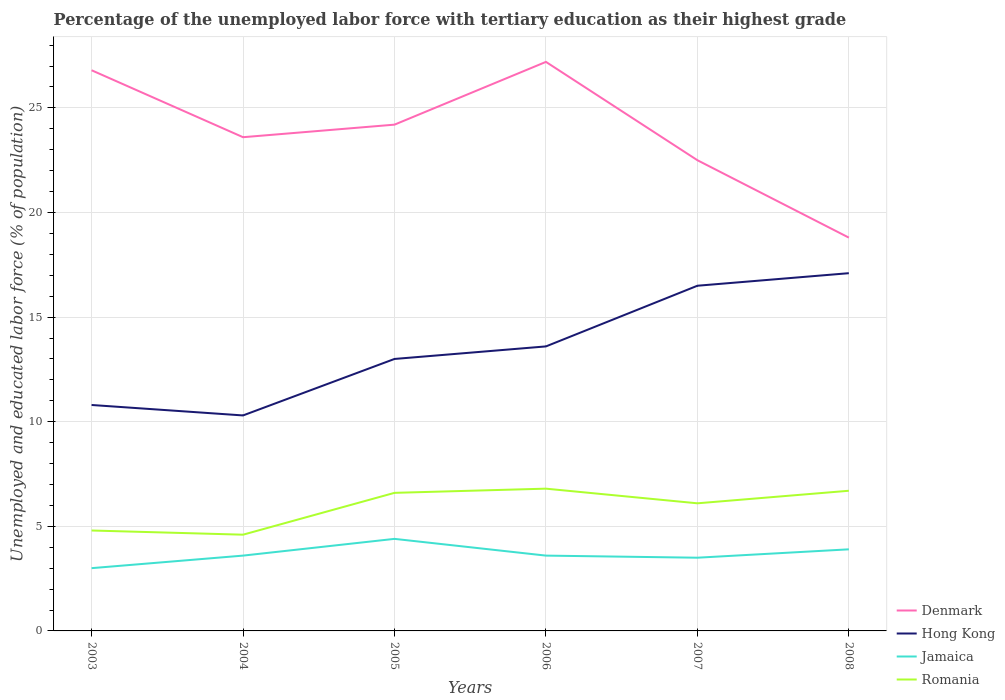Does the line corresponding to Hong Kong intersect with the line corresponding to Jamaica?
Your response must be concise. No. Is the number of lines equal to the number of legend labels?
Your response must be concise. Yes. Across all years, what is the maximum percentage of the unemployed labor force with tertiary education in Jamaica?
Ensure brevity in your answer.  3. What is the difference between the highest and the second highest percentage of the unemployed labor force with tertiary education in Jamaica?
Your answer should be very brief. 1.4. How many lines are there?
Give a very brief answer. 4. How many years are there in the graph?
Your response must be concise. 6. Does the graph contain any zero values?
Provide a succinct answer. No. Does the graph contain grids?
Provide a short and direct response. Yes. What is the title of the graph?
Your response must be concise. Percentage of the unemployed labor force with tertiary education as their highest grade. Does "Moldova" appear as one of the legend labels in the graph?
Ensure brevity in your answer.  No. What is the label or title of the X-axis?
Provide a short and direct response. Years. What is the label or title of the Y-axis?
Give a very brief answer. Unemployed and educated labor force (% of population). What is the Unemployed and educated labor force (% of population) of Denmark in 2003?
Ensure brevity in your answer.  26.8. What is the Unemployed and educated labor force (% of population) in Hong Kong in 2003?
Offer a terse response. 10.8. What is the Unemployed and educated labor force (% of population) of Romania in 2003?
Make the answer very short. 4.8. What is the Unemployed and educated labor force (% of population) in Denmark in 2004?
Make the answer very short. 23.6. What is the Unemployed and educated labor force (% of population) in Hong Kong in 2004?
Offer a very short reply. 10.3. What is the Unemployed and educated labor force (% of population) in Jamaica in 2004?
Your answer should be very brief. 3.6. What is the Unemployed and educated labor force (% of population) of Romania in 2004?
Make the answer very short. 4.6. What is the Unemployed and educated labor force (% of population) of Denmark in 2005?
Keep it short and to the point. 24.2. What is the Unemployed and educated labor force (% of population) in Jamaica in 2005?
Your answer should be compact. 4.4. What is the Unemployed and educated labor force (% of population) of Romania in 2005?
Provide a succinct answer. 6.6. What is the Unemployed and educated labor force (% of population) of Denmark in 2006?
Make the answer very short. 27.2. What is the Unemployed and educated labor force (% of population) of Hong Kong in 2006?
Keep it short and to the point. 13.6. What is the Unemployed and educated labor force (% of population) of Jamaica in 2006?
Provide a short and direct response. 3.6. What is the Unemployed and educated labor force (% of population) of Romania in 2006?
Ensure brevity in your answer.  6.8. What is the Unemployed and educated labor force (% of population) in Denmark in 2007?
Your answer should be very brief. 22.5. What is the Unemployed and educated labor force (% of population) of Jamaica in 2007?
Your answer should be compact. 3.5. What is the Unemployed and educated labor force (% of population) in Romania in 2007?
Make the answer very short. 6.1. What is the Unemployed and educated labor force (% of population) in Denmark in 2008?
Your answer should be very brief. 18.8. What is the Unemployed and educated labor force (% of population) of Hong Kong in 2008?
Offer a very short reply. 17.1. What is the Unemployed and educated labor force (% of population) in Jamaica in 2008?
Give a very brief answer. 3.9. What is the Unemployed and educated labor force (% of population) in Romania in 2008?
Provide a succinct answer. 6.7. Across all years, what is the maximum Unemployed and educated labor force (% of population) of Denmark?
Give a very brief answer. 27.2. Across all years, what is the maximum Unemployed and educated labor force (% of population) in Hong Kong?
Provide a short and direct response. 17.1. Across all years, what is the maximum Unemployed and educated labor force (% of population) in Jamaica?
Keep it short and to the point. 4.4. Across all years, what is the maximum Unemployed and educated labor force (% of population) in Romania?
Your answer should be compact. 6.8. Across all years, what is the minimum Unemployed and educated labor force (% of population) in Denmark?
Your answer should be compact. 18.8. Across all years, what is the minimum Unemployed and educated labor force (% of population) of Hong Kong?
Offer a terse response. 10.3. Across all years, what is the minimum Unemployed and educated labor force (% of population) in Romania?
Provide a short and direct response. 4.6. What is the total Unemployed and educated labor force (% of population) of Denmark in the graph?
Your answer should be compact. 143.1. What is the total Unemployed and educated labor force (% of population) in Hong Kong in the graph?
Give a very brief answer. 81.3. What is the total Unemployed and educated labor force (% of population) in Romania in the graph?
Ensure brevity in your answer.  35.6. What is the difference between the Unemployed and educated labor force (% of population) in Jamaica in 2003 and that in 2004?
Provide a succinct answer. -0.6. What is the difference between the Unemployed and educated labor force (% of population) of Denmark in 2003 and that in 2005?
Your answer should be very brief. 2.6. What is the difference between the Unemployed and educated labor force (% of population) in Hong Kong in 2003 and that in 2005?
Offer a very short reply. -2.2. What is the difference between the Unemployed and educated labor force (% of population) in Romania in 2003 and that in 2005?
Ensure brevity in your answer.  -1.8. What is the difference between the Unemployed and educated labor force (% of population) in Denmark in 2003 and that in 2006?
Your response must be concise. -0.4. What is the difference between the Unemployed and educated labor force (% of population) in Hong Kong in 2003 and that in 2006?
Make the answer very short. -2.8. What is the difference between the Unemployed and educated labor force (% of population) in Jamaica in 2003 and that in 2006?
Provide a short and direct response. -0.6. What is the difference between the Unemployed and educated labor force (% of population) in Romania in 2003 and that in 2006?
Your response must be concise. -2. What is the difference between the Unemployed and educated labor force (% of population) in Jamaica in 2003 and that in 2007?
Your response must be concise. -0.5. What is the difference between the Unemployed and educated labor force (% of population) in Romania in 2003 and that in 2007?
Provide a succinct answer. -1.3. What is the difference between the Unemployed and educated labor force (% of population) of Denmark in 2003 and that in 2008?
Offer a terse response. 8. What is the difference between the Unemployed and educated labor force (% of population) in Jamaica in 2003 and that in 2008?
Offer a terse response. -0.9. What is the difference between the Unemployed and educated labor force (% of population) in Denmark in 2004 and that in 2005?
Ensure brevity in your answer.  -0.6. What is the difference between the Unemployed and educated labor force (% of population) in Romania in 2004 and that in 2005?
Make the answer very short. -2. What is the difference between the Unemployed and educated labor force (% of population) in Denmark in 2004 and that in 2007?
Your response must be concise. 1.1. What is the difference between the Unemployed and educated labor force (% of population) in Romania in 2004 and that in 2007?
Offer a terse response. -1.5. What is the difference between the Unemployed and educated labor force (% of population) of Jamaica in 2004 and that in 2008?
Keep it short and to the point. -0.3. What is the difference between the Unemployed and educated labor force (% of population) in Denmark in 2005 and that in 2006?
Your answer should be very brief. -3. What is the difference between the Unemployed and educated labor force (% of population) in Jamaica in 2005 and that in 2007?
Your answer should be very brief. 0.9. What is the difference between the Unemployed and educated labor force (% of population) in Romania in 2005 and that in 2007?
Ensure brevity in your answer.  0.5. What is the difference between the Unemployed and educated labor force (% of population) in Denmark in 2005 and that in 2008?
Provide a short and direct response. 5.4. What is the difference between the Unemployed and educated labor force (% of population) of Jamaica in 2005 and that in 2008?
Make the answer very short. 0.5. What is the difference between the Unemployed and educated labor force (% of population) of Denmark in 2006 and that in 2007?
Provide a succinct answer. 4.7. What is the difference between the Unemployed and educated labor force (% of population) of Hong Kong in 2006 and that in 2007?
Your answer should be very brief. -2.9. What is the difference between the Unemployed and educated labor force (% of population) of Jamaica in 2006 and that in 2007?
Offer a terse response. 0.1. What is the difference between the Unemployed and educated labor force (% of population) of Hong Kong in 2007 and that in 2008?
Provide a succinct answer. -0.6. What is the difference between the Unemployed and educated labor force (% of population) in Jamaica in 2007 and that in 2008?
Keep it short and to the point. -0.4. What is the difference between the Unemployed and educated labor force (% of population) in Romania in 2007 and that in 2008?
Offer a very short reply. -0.6. What is the difference between the Unemployed and educated labor force (% of population) of Denmark in 2003 and the Unemployed and educated labor force (% of population) of Hong Kong in 2004?
Make the answer very short. 16.5. What is the difference between the Unemployed and educated labor force (% of population) of Denmark in 2003 and the Unemployed and educated labor force (% of population) of Jamaica in 2004?
Offer a terse response. 23.2. What is the difference between the Unemployed and educated labor force (% of population) of Hong Kong in 2003 and the Unemployed and educated labor force (% of population) of Jamaica in 2004?
Your answer should be very brief. 7.2. What is the difference between the Unemployed and educated labor force (% of population) in Denmark in 2003 and the Unemployed and educated labor force (% of population) in Hong Kong in 2005?
Your answer should be compact. 13.8. What is the difference between the Unemployed and educated labor force (% of population) of Denmark in 2003 and the Unemployed and educated labor force (% of population) of Jamaica in 2005?
Offer a very short reply. 22.4. What is the difference between the Unemployed and educated labor force (% of population) in Denmark in 2003 and the Unemployed and educated labor force (% of population) in Romania in 2005?
Offer a terse response. 20.2. What is the difference between the Unemployed and educated labor force (% of population) of Jamaica in 2003 and the Unemployed and educated labor force (% of population) of Romania in 2005?
Ensure brevity in your answer.  -3.6. What is the difference between the Unemployed and educated labor force (% of population) in Denmark in 2003 and the Unemployed and educated labor force (% of population) in Jamaica in 2006?
Offer a very short reply. 23.2. What is the difference between the Unemployed and educated labor force (% of population) in Denmark in 2003 and the Unemployed and educated labor force (% of population) in Romania in 2006?
Your answer should be compact. 20. What is the difference between the Unemployed and educated labor force (% of population) of Hong Kong in 2003 and the Unemployed and educated labor force (% of population) of Jamaica in 2006?
Make the answer very short. 7.2. What is the difference between the Unemployed and educated labor force (% of population) of Hong Kong in 2003 and the Unemployed and educated labor force (% of population) of Romania in 2006?
Your answer should be very brief. 4. What is the difference between the Unemployed and educated labor force (% of population) of Denmark in 2003 and the Unemployed and educated labor force (% of population) of Hong Kong in 2007?
Provide a short and direct response. 10.3. What is the difference between the Unemployed and educated labor force (% of population) of Denmark in 2003 and the Unemployed and educated labor force (% of population) of Jamaica in 2007?
Ensure brevity in your answer.  23.3. What is the difference between the Unemployed and educated labor force (% of population) in Denmark in 2003 and the Unemployed and educated labor force (% of population) in Romania in 2007?
Your answer should be compact. 20.7. What is the difference between the Unemployed and educated labor force (% of population) in Hong Kong in 2003 and the Unemployed and educated labor force (% of population) in Jamaica in 2007?
Give a very brief answer. 7.3. What is the difference between the Unemployed and educated labor force (% of population) of Denmark in 2003 and the Unemployed and educated labor force (% of population) of Jamaica in 2008?
Your response must be concise. 22.9. What is the difference between the Unemployed and educated labor force (% of population) of Denmark in 2003 and the Unemployed and educated labor force (% of population) of Romania in 2008?
Provide a succinct answer. 20.1. What is the difference between the Unemployed and educated labor force (% of population) in Hong Kong in 2003 and the Unemployed and educated labor force (% of population) in Jamaica in 2008?
Ensure brevity in your answer.  6.9. What is the difference between the Unemployed and educated labor force (% of population) in Hong Kong in 2003 and the Unemployed and educated labor force (% of population) in Romania in 2008?
Make the answer very short. 4.1. What is the difference between the Unemployed and educated labor force (% of population) of Jamaica in 2003 and the Unemployed and educated labor force (% of population) of Romania in 2008?
Give a very brief answer. -3.7. What is the difference between the Unemployed and educated labor force (% of population) of Denmark in 2004 and the Unemployed and educated labor force (% of population) of Hong Kong in 2005?
Your answer should be compact. 10.6. What is the difference between the Unemployed and educated labor force (% of population) in Hong Kong in 2004 and the Unemployed and educated labor force (% of population) in Jamaica in 2005?
Make the answer very short. 5.9. What is the difference between the Unemployed and educated labor force (% of population) of Hong Kong in 2004 and the Unemployed and educated labor force (% of population) of Romania in 2005?
Your response must be concise. 3.7. What is the difference between the Unemployed and educated labor force (% of population) in Denmark in 2004 and the Unemployed and educated labor force (% of population) in Jamaica in 2006?
Provide a short and direct response. 20. What is the difference between the Unemployed and educated labor force (% of population) of Denmark in 2004 and the Unemployed and educated labor force (% of population) of Romania in 2006?
Give a very brief answer. 16.8. What is the difference between the Unemployed and educated labor force (% of population) of Jamaica in 2004 and the Unemployed and educated labor force (% of population) of Romania in 2006?
Offer a terse response. -3.2. What is the difference between the Unemployed and educated labor force (% of population) in Denmark in 2004 and the Unemployed and educated labor force (% of population) in Jamaica in 2007?
Provide a succinct answer. 20.1. What is the difference between the Unemployed and educated labor force (% of population) in Denmark in 2004 and the Unemployed and educated labor force (% of population) in Romania in 2008?
Make the answer very short. 16.9. What is the difference between the Unemployed and educated labor force (% of population) in Hong Kong in 2004 and the Unemployed and educated labor force (% of population) in Romania in 2008?
Ensure brevity in your answer.  3.6. What is the difference between the Unemployed and educated labor force (% of population) of Jamaica in 2004 and the Unemployed and educated labor force (% of population) of Romania in 2008?
Provide a succinct answer. -3.1. What is the difference between the Unemployed and educated labor force (% of population) of Denmark in 2005 and the Unemployed and educated labor force (% of population) of Jamaica in 2006?
Make the answer very short. 20.6. What is the difference between the Unemployed and educated labor force (% of population) of Hong Kong in 2005 and the Unemployed and educated labor force (% of population) of Jamaica in 2006?
Provide a short and direct response. 9.4. What is the difference between the Unemployed and educated labor force (% of population) in Hong Kong in 2005 and the Unemployed and educated labor force (% of population) in Romania in 2006?
Provide a succinct answer. 6.2. What is the difference between the Unemployed and educated labor force (% of population) of Denmark in 2005 and the Unemployed and educated labor force (% of population) of Jamaica in 2007?
Ensure brevity in your answer.  20.7. What is the difference between the Unemployed and educated labor force (% of population) in Denmark in 2005 and the Unemployed and educated labor force (% of population) in Romania in 2007?
Your answer should be very brief. 18.1. What is the difference between the Unemployed and educated labor force (% of population) of Hong Kong in 2005 and the Unemployed and educated labor force (% of population) of Jamaica in 2007?
Your response must be concise. 9.5. What is the difference between the Unemployed and educated labor force (% of population) of Jamaica in 2005 and the Unemployed and educated labor force (% of population) of Romania in 2007?
Your answer should be very brief. -1.7. What is the difference between the Unemployed and educated labor force (% of population) of Denmark in 2005 and the Unemployed and educated labor force (% of population) of Hong Kong in 2008?
Give a very brief answer. 7.1. What is the difference between the Unemployed and educated labor force (% of population) in Denmark in 2005 and the Unemployed and educated labor force (% of population) in Jamaica in 2008?
Provide a short and direct response. 20.3. What is the difference between the Unemployed and educated labor force (% of population) of Denmark in 2005 and the Unemployed and educated labor force (% of population) of Romania in 2008?
Your answer should be very brief. 17.5. What is the difference between the Unemployed and educated labor force (% of population) of Hong Kong in 2005 and the Unemployed and educated labor force (% of population) of Jamaica in 2008?
Offer a terse response. 9.1. What is the difference between the Unemployed and educated labor force (% of population) in Denmark in 2006 and the Unemployed and educated labor force (% of population) in Hong Kong in 2007?
Give a very brief answer. 10.7. What is the difference between the Unemployed and educated labor force (% of population) in Denmark in 2006 and the Unemployed and educated labor force (% of population) in Jamaica in 2007?
Ensure brevity in your answer.  23.7. What is the difference between the Unemployed and educated labor force (% of population) of Denmark in 2006 and the Unemployed and educated labor force (% of population) of Romania in 2007?
Provide a short and direct response. 21.1. What is the difference between the Unemployed and educated labor force (% of population) of Hong Kong in 2006 and the Unemployed and educated labor force (% of population) of Romania in 2007?
Give a very brief answer. 7.5. What is the difference between the Unemployed and educated labor force (% of population) in Jamaica in 2006 and the Unemployed and educated labor force (% of population) in Romania in 2007?
Give a very brief answer. -2.5. What is the difference between the Unemployed and educated labor force (% of population) in Denmark in 2006 and the Unemployed and educated labor force (% of population) in Jamaica in 2008?
Your answer should be very brief. 23.3. What is the difference between the Unemployed and educated labor force (% of population) in Denmark in 2007 and the Unemployed and educated labor force (% of population) in Jamaica in 2008?
Keep it short and to the point. 18.6. What is the difference between the Unemployed and educated labor force (% of population) of Denmark in 2007 and the Unemployed and educated labor force (% of population) of Romania in 2008?
Your answer should be compact. 15.8. What is the difference between the Unemployed and educated labor force (% of population) of Hong Kong in 2007 and the Unemployed and educated labor force (% of population) of Jamaica in 2008?
Provide a short and direct response. 12.6. What is the difference between the Unemployed and educated labor force (% of population) in Hong Kong in 2007 and the Unemployed and educated labor force (% of population) in Romania in 2008?
Offer a very short reply. 9.8. What is the average Unemployed and educated labor force (% of population) of Denmark per year?
Your answer should be very brief. 23.85. What is the average Unemployed and educated labor force (% of population) of Hong Kong per year?
Ensure brevity in your answer.  13.55. What is the average Unemployed and educated labor force (% of population) of Jamaica per year?
Your response must be concise. 3.67. What is the average Unemployed and educated labor force (% of population) in Romania per year?
Give a very brief answer. 5.93. In the year 2003, what is the difference between the Unemployed and educated labor force (% of population) of Denmark and Unemployed and educated labor force (% of population) of Hong Kong?
Your answer should be compact. 16. In the year 2003, what is the difference between the Unemployed and educated labor force (% of population) of Denmark and Unemployed and educated labor force (% of population) of Jamaica?
Your answer should be very brief. 23.8. In the year 2003, what is the difference between the Unemployed and educated labor force (% of population) in Hong Kong and Unemployed and educated labor force (% of population) in Romania?
Offer a terse response. 6. In the year 2004, what is the difference between the Unemployed and educated labor force (% of population) in Hong Kong and Unemployed and educated labor force (% of population) in Romania?
Offer a terse response. 5.7. In the year 2004, what is the difference between the Unemployed and educated labor force (% of population) of Jamaica and Unemployed and educated labor force (% of population) of Romania?
Your answer should be very brief. -1. In the year 2005, what is the difference between the Unemployed and educated labor force (% of population) in Denmark and Unemployed and educated labor force (% of population) in Hong Kong?
Offer a very short reply. 11.2. In the year 2005, what is the difference between the Unemployed and educated labor force (% of population) of Denmark and Unemployed and educated labor force (% of population) of Jamaica?
Make the answer very short. 19.8. In the year 2005, what is the difference between the Unemployed and educated labor force (% of population) in Hong Kong and Unemployed and educated labor force (% of population) in Romania?
Provide a succinct answer. 6.4. In the year 2006, what is the difference between the Unemployed and educated labor force (% of population) of Denmark and Unemployed and educated labor force (% of population) of Jamaica?
Your answer should be compact. 23.6. In the year 2006, what is the difference between the Unemployed and educated labor force (% of population) in Denmark and Unemployed and educated labor force (% of population) in Romania?
Keep it short and to the point. 20.4. In the year 2006, what is the difference between the Unemployed and educated labor force (% of population) in Hong Kong and Unemployed and educated labor force (% of population) in Jamaica?
Keep it short and to the point. 10. In the year 2006, what is the difference between the Unemployed and educated labor force (% of population) in Hong Kong and Unemployed and educated labor force (% of population) in Romania?
Provide a succinct answer. 6.8. In the year 2007, what is the difference between the Unemployed and educated labor force (% of population) of Denmark and Unemployed and educated labor force (% of population) of Hong Kong?
Offer a terse response. 6. In the year 2007, what is the difference between the Unemployed and educated labor force (% of population) of Hong Kong and Unemployed and educated labor force (% of population) of Romania?
Your response must be concise. 10.4. In the year 2007, what is the difference between the Unemployed and educated labor force (% of population) of Jamaica and Unemployed and educated labor force (% of population) of Romania?
Your answer should be very brief. -2.6. In the year 2008, what is the difference between the Unemployed and educated labor force (% of population) in Denmark and Unemployed and educated labor force (% of population) in Jamaica?
Keep it short and to the point. 14.9. In the year 2008, what is the difference between the Unemployed and educated labor force (% of population) in Jamaica and Unemployed and educated labor force (% of population) in Romania?
Give a very brief answer. -2.8. What is the ratio of the Unemployed and educated labor force (% of population) of Denmark in 2003 to that in 2004?
Make the answer very short. 1.14. What is the ratio of the Unemployed and educated labor force (% of population) of Hong Kong in 2003 to that in 2004?
Your answer should be very brief. 1.05. What is the ratio of the Unemployed and educated labor force (% of population) in Jamaica in 2003 to that in 2004?
Keep it short and to the point. 0.83. What is the ratio of the Unemployed and educated labor force (% of population) in Romania in 2003 to that in 2004?
Offer a very short reply. 1.04. What is the ratio of the Unemployed and educated labor force (% of population) in Denmark in 2003 to that in 2005?
Your response must be concise. 1.11. What is the ratio of the Unemployed and educated labor force (% of population) in Hong Kong in 2003 to that in 2005?
Offer a terse response. 0.83. What is the ratio of the Unemployed and educated labor force (% of population) of Jamaica in 2003 to that in 2005?
Give a very brief answer. 0.68. What is the ratio of the Unemployed and educated labor force (% of population) in Romania in 2003 to that in 2005?
Make the answer very short. 0.73. What is the ratio of the Unemployed and educated labor force (% of population) of Denmark in 2003 to that in 2006?
Your answer should be compact. 0.99. What is the ratio of the Unemployed and educated labor force (% of population) in Hong Kong in 2003 to that in 2006?
Your answer should be very brief. 0.79. What is the ratio of the Unemployed and educated labor force (% of population) in Romania in 2003 to that in 2006?
Ensure brevity in your answer.  0.71. What is the ratio of the Unemployed and educated labor force (% of population) in Denmark in 2003 to that in 2007?
Make the answer very short. 1.19. What is the ratio of the Unemployed and educated labor force (% of population) in Hong Kong in 2003 to that in 2007?
Give a very brief answer. 0.65. What is the ratio of the Unemployed and educated labor force (% of population) of Romania in 2003 to that in 2007?
Provide a succinct answer. 0.79. What is the ratio of the Unemployed and educated labor force (% of population) of Denmark in 2003 to that in 2008?
Offer a terse response. 1.43. What is the ratio of the Unemployed and educated labor force (% of population) in Hong Kong in 2003 to that in 2008?
Provide a succinct answer. 0.63. What is the ratio of the Unemployed and educated labor force (% of population) in Jamaica in 2003 to that in 2008?
Keep it short and to the point. 0.77. What is the ratio of the Unemployed and educated labor force (% of population) in Romania in 2003 to that in 2008?
Offer a very short reply. 0.72. What is the ratio of the Unemployed and educated labor force (% of population) in Denmark in 2004 to that in 2005?
Provide a succinct answer. 0.98. What is the ratio of the Unemployed and educated labor force (% of population) in Hong Kong in 2004 to that in 2005?
Ensure brevity in your answer.  0.79. What is the ratio of the Unemployed and educated labor force (% of population) of Jamaica in 2004 to that in 2005?
Offer a terse response. 0.82. What is the ratio of the Unemployed and educated labor force (% of population) of Romania in 2004 to that in 2005?
Provide a succinct answer. 0.7. What is the ratio of the Unemployed and educated labor force (% of population) of Denmark in 2004 to that in 2006?
Offer a terse response. 0.87. What is the ratio of the Unemployed and educated labor force (% of population) in Hong Kong in 2004 to that in 2006?
Your answer should be compact. 0.76. What is the ratio of the Unemployed and educated labor force (% of population) of Jamaica in 2004 to that in 2006?
Offer a very short reply. 1. What is the ratio of the Unemployed and educated labor force (% of population) of Romania in 2004 to that in 2006?
Give a very brief answer. 0.68. What is the ratio of the Unemployed and educated labor force (% of population) in Denmark in 2004 to that in 2007?
Keep it short and to the point. 1.05. What is the ratio of the Unemployed and educated labor force (% of population) in Hong Kong in 2004 to that in 2007?
Make the answer very short. 0.62. What is the ratio of the Unemployed and educated labor force (% of population) of Jamaica in 2004 to that in 2007?
Offer a terse response. 1.03. What is the ratio of the Unemployed and educated labor force (% of population) of Romania in 2004 to that in 2007?
Provide a short and direct response. 0.75. What is the ratio of the Unemployed and educated labor force (% of population) of Denmark in 2004 to that in 2008?
Keep it short and to the point. 1.26. What is the ratio of the Unemployed and educated labor force (% of population) of Hong Kong in 2004 to that in 2008?
Provide a succinct answer. 0.6. What is the ratio of the Unemployed and educated labor force (% of population) in Jamaica in 2004 to that in 2008?
Provide a succinct answer. 0.92. What is the ratio of the Unemployed and educated labor force (% of population) in Romania in 2004 to that in 2008?
Ensure brevity in your answer.  0.69. What is the ratio of the Unemployed and educated labor force (% of population) of Denmark in 2005 to that in 2006?
Keep it short and to the point. 0.89. What is the ratio of the Unemployed and educated labor force (% of population) of Hong Kong in 2005 to that in 2006?
Provide a short and direct response. 0.96. What is the ratio of the Unemployed and educated labor force (% of population) in Jamaica in 2005 to that in 2006?
Offer a terse response. 1.22. What is the ratio of the Unemployed and educated labor force (% of population) of Romania in 2005 to that in 2006?
Make the answer very short. 0.97. What is the ratio of the Unemployed and educated labor force (% of population) of Denmark in 2005 to that in 2007?
Make the answer very short. 1.08. What is the ratio of the Unemployed and educated labor force (% of population) of Hong Kong in 2005 to that in 2007?
Make the answer very short. 0.79. What is the ratio of the Unemployed and educated labor force (% of population) in Jamaica in 2005 to that in 2007?
Your answer should be very brief. 1.26. What is the ratio of the Unemployed and educated labor force (% of population) in Romania in 2005 to that in 2007?
Make the answer very short. 1.08. What is the ratio of the Unemployed and educated labor force (% of population) in Denmark in 2005 to that in 2008?
Provide a succinct answer. 1.29. What is the ratio of the Unemployed and educated labor force (% of population) of Hong Kong in 2005 to that in 2008?
Make the answer very short. 0.76. What is the ratio of the Unemployed and educated labor force (% of population) of Jamaica in 2005 to that in 2008?
Your answer should be compact. 1.13. What is the ratio of the Unemployed and educated labor force (% of population) of Romania in 2005 to that in 2008?
Provide a short and direct response. 0.99. What is the ratio of the Unemployed and educated labor force (% of population) in Denmark in 2006 to that in 2007?
Offer a very short reply. 1.21. What is the ratio of the Unemployed and educated labor force (% of population) of Hong Kong in 2006 to that in 2007?
Your answer should be compact. 0.82. What is the ratio of the Unemployed and educated labor force (% of population) of Jamaica in 2006 to that in 2007?
Keep it short and to the point. 1.03. What is the ratio of the Unemployed and educated labor force (% of population) of Romania in 2006 to that in 2007?
Make the answer very short. 1.11. What is the ratio of the Unemployed and educated labor force (% of population) in Denmark in 2006 to that in 2008?
Your answer should be compact. 1.45. What is the ratio of the Unemployed and educated labor force (% of population) in Hong Kong in 2006 to that in 2008?
Give a very brief answer. 0.8. What is the ratio of the Unemployed and educated labor force (% of population) in Romania in 2006 to that in 2008?
Make the answer very short. 1.01. What is the ratio of the Unemployed and educated labor force (% of population) of Denmark in 2007 to that in 2008?
Your answer should be compact. 1.2. What is the ratio of the Unemployed and educated labor force (% of population) in Hong Kong in 2007 to that in 2008?
Your answer should be compact. 0.96. What is the ratio of the Unemployed and educated labor force (% of population) of Jamaica in 2007 to that in 2008?
Make the answer very short. 0.9. What is the ratio of the Unemployed and educated labor force (% of population) in Romania in 2007 to that in 2008?
Ensure brevity in your answer.  0.91. What is the difference between the highest and the second highest Unemployed and educated labor force (% of population) in Denmark?
Make the answer very short. 0.4. What is the difference between the highest and the second highest Unemployed and educated labor force (% of population) of Jamaica?
Your response must be concise. 0.5. What is the difference between the highest and the second highest Unemployed and educated labor force (% of population) in Romania?
Your response must be concise. 0.1. What is the difference between the highest and the lowest Unemployed and educated labor force (% of population) of Denmark?
Provide a short and direct response. 8.4. What is the difference between the highest and the lowest Unemployed and educated labor force (% of population) of Hong Kong?
Your answer should be compact. 6.8. What is the difference between the highest and the lowest Unemployed and educated labor force (% of population) in Jamaica?
Make the answer very short. 1.4. 